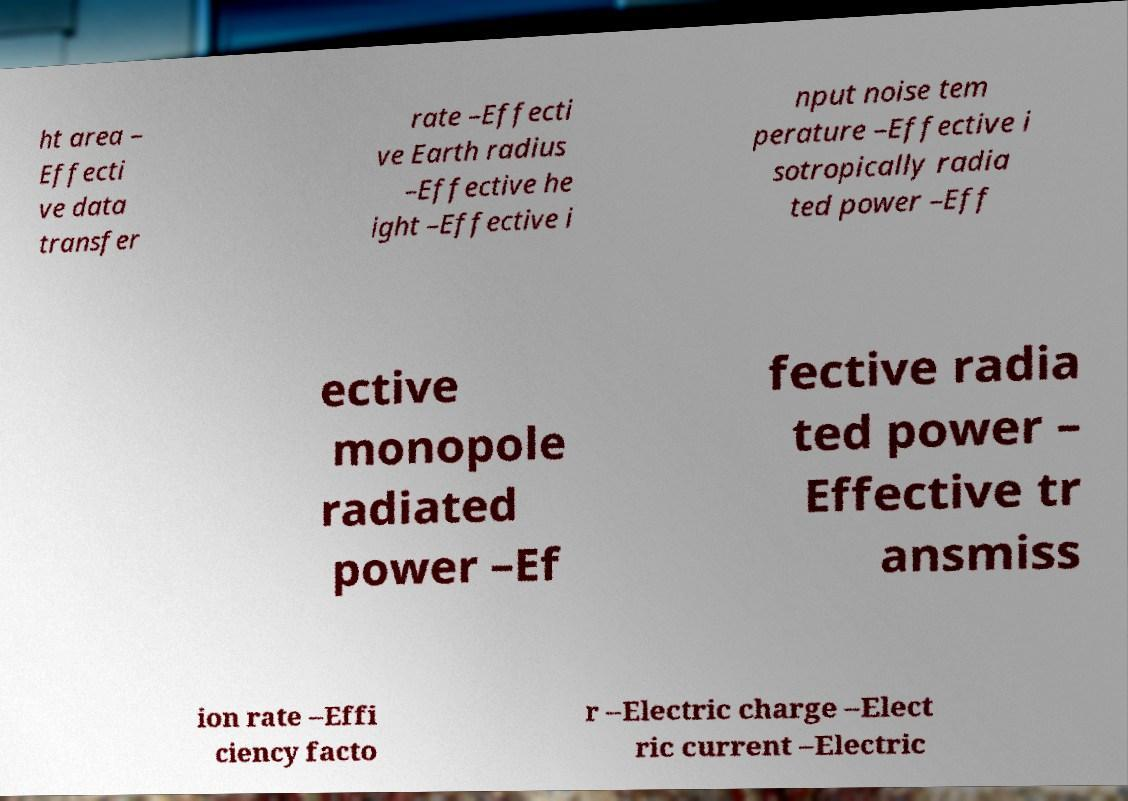There's text embedded in this image that I need extracted. Can you transcribe it verbatim? ht area – Effecti ve data transfer rate –Effecti ve Earth radius –Effective he ight –Effective i nput noise tem perature –Effective i sotropically radia ted power –Eff ective monopole radiated power –Ef fective radia ted power – Effective tr ansmiss ion rate –Effi ciency facto r –Electric charge –Elect ric current –Electric 